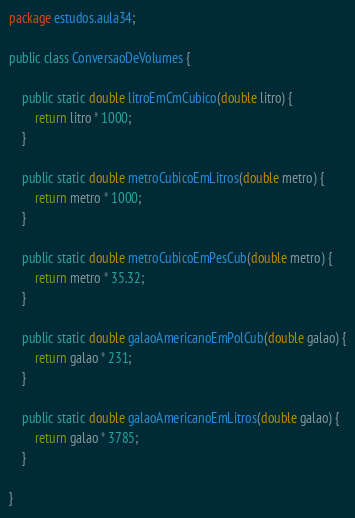<code> <loc_0><loc_0><loc_500><loc_500><_Java_>package estudos.aula34;

public class ConversaoDeVolumes {

	public static double litroEmCmCubico(double litro) {
		return litro * 1000;
	}

	public static double metroCubicoEmLitros(double metro) {
		return metro * 1000;
	}
	
	public static double metroCubicoEmPesCub(double metro) {
		return metro * 35.32;
	}
	
	public static double galaoAmericanoEmPolCub(double galao) {
		return galao * 231;
	}
	
	public static double galaoAmericanoEmLitros(double galao) {
		return galao * 3785;
	}
	
}</code> 